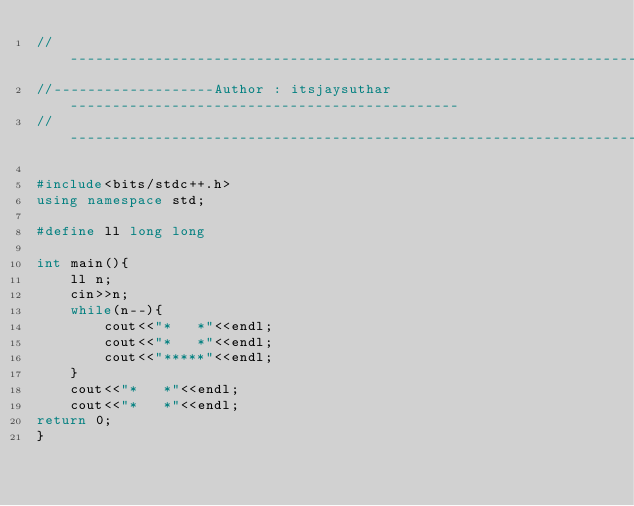<code> <loc_0><loc_0><loc_500><loc_500><_C++_>//---------------------------------------------------------------------------------------
//-------------------Author : itsjaysuthar ----------------------------------------------
//---------------------------------------------------------------------------------------

#include<bits/stdc++.h>
using namespace std;

#define ll long long

int main(){
    ll n;
    cin>>n;
    while(n--){
        cout<<"*   *"<<endl;
        cout<<"*   *"<<endl;
        cout<<"*****"<<endl;
    }
    cout<<"*   *"<<endl;
    cout<<"*   *"<<endl;
return 0;
}

</code> 